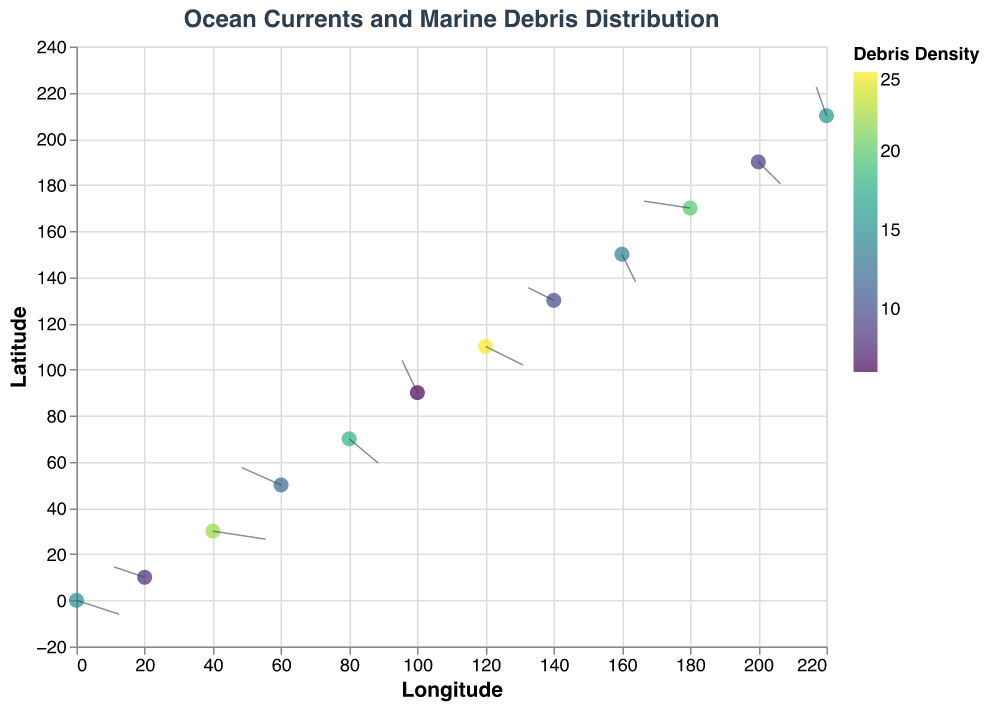What's the title of this plot? The title is prominently displayed at the top of the plot.
Answer: Ocean Currents and Marine Debris Distribution What do the arrows in the plot represent? The arrows indicate the direction and velocity of ocean currents based on their length and orientation.
Answer: Ocean currents Which point has the highest debris density, and what is the value? By looking at the color gradient and tooltip information, the point at (120, 110) has the highest debris density.
Answer: 25 How does debris density change from the point at (0, 0) to (120, 110)? The debris density increases from 15 at (0, 0) to 25 at (120, 110).
Answer: Increases Do points with higher debris density tend to have stronger or weaker currents? By comparing the arrow lengths (representing current strength) and the color (debris density), points with higher debris density often have stronger currents. For example, (120, 110) with a debris density of 25 has a notable current of (2.2, -1.6).
Answer: Stronger currents What is the direction of the current at point (80, 70)? The arrow at (80, 70) points downward and to the right, indicating the current direction.
Answer: Downward and right Compare the currents at (40, 30) and (180, 170). Which one has a stronger current? By checking the lengths of the arrows, the point (40, 30) has a current of (3.1, -0.7) while (180, 170) has a current of (-2.7, 0.6). The magnitude of the currents can be compared using Pythagoras’ theorem: √(3.1² + 0.7²) ≈ 3.16 and √(2.7² + 0.6²) ≈ 2.75.
Answer: (40, 30) What happens to the debris density as we move from (20, 10) to (60, 50)? The debris density increases from 8 to 12.
Answer: Increases Which point has the largest negative x-component of the current, and what is its value? By identifying the arrow components, the point (180, 170) has the largest negative x-component of -2.7.
Answer: (180, 170); -2.7 What pattern do you observe between the debris densities and the color gradient? The color gradient ranges from yellow to green to blue. Higher debris densities correspond to more vibrant colors (e.g., point (120, 110) with debris density 25 is brightly colored).
Answer: Higher densities are more vibrant 